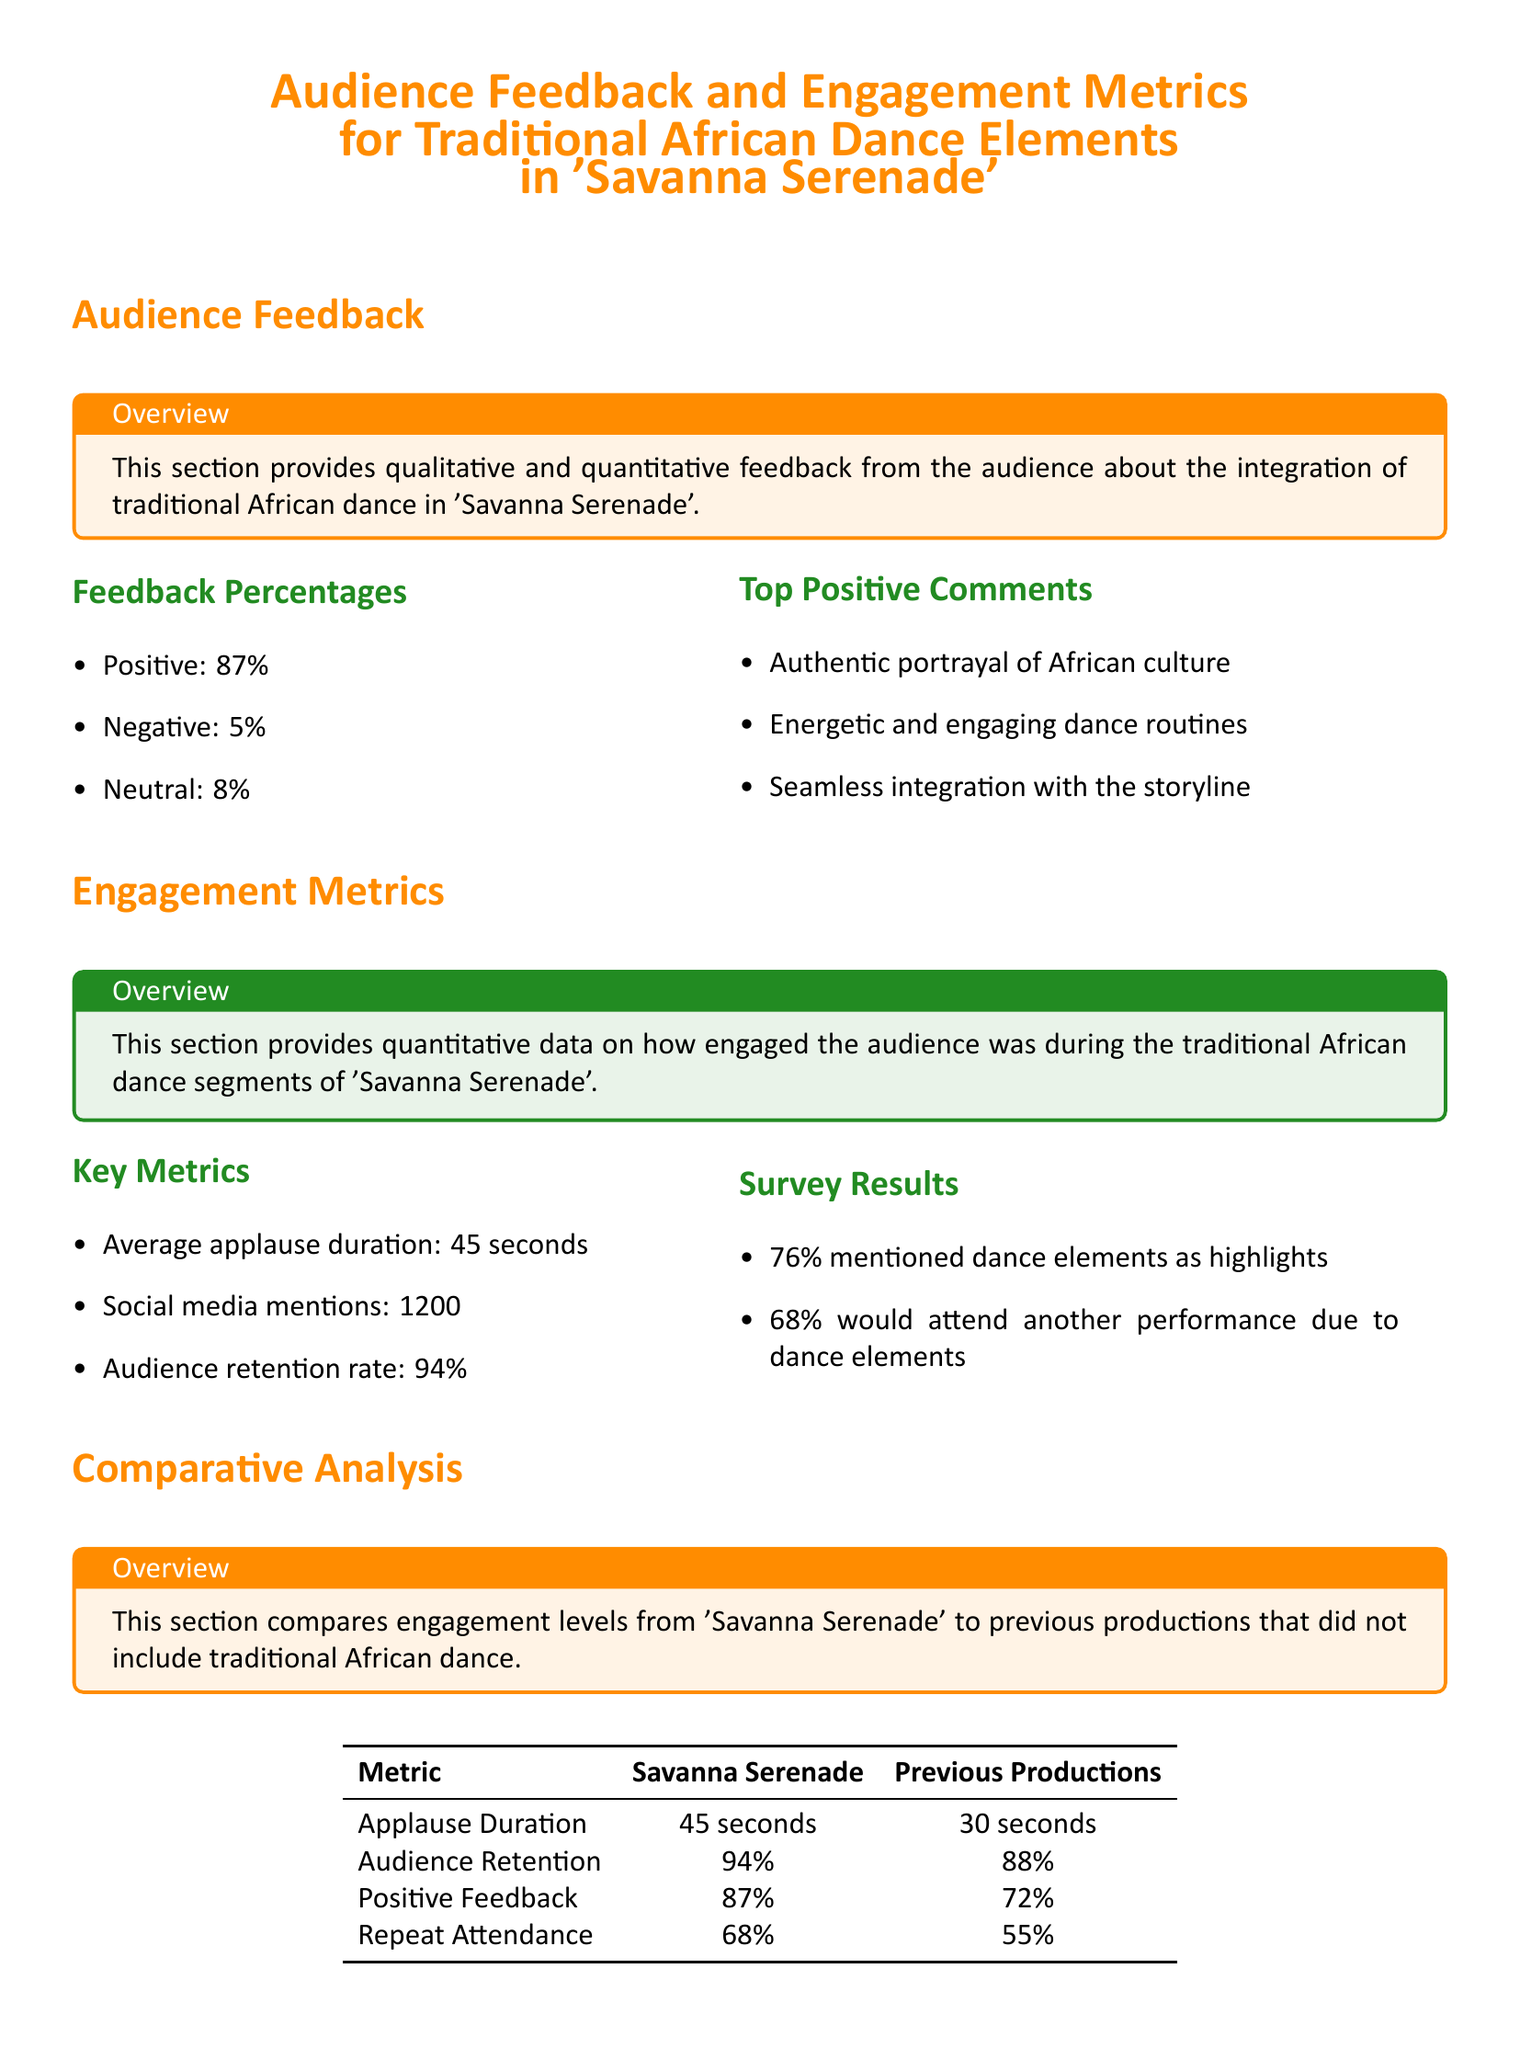What percentage of positive feedback was received? The percentage of positive feedback is presented in the document as one of the key metrics, specifically noting it as 87%.
Answer: 87% What is the average applause duration for the dance segments? The document provides the average applause duration as one of the key engagement metrics, specifically noted as 45 seconds.
Answer: 45 seconds What percent of the audience mentioned dance elements as highlights? The survey results section specifies that 76% of the audience mentioned dance elements as highlights in their feedback.
Answer: 76% What was the audience retention rate for 'Savanna Serenade'? The audience retention rate is listed in the engagement metrics, explicitly noted as 94%.
Answer: 94% What recommendation is suggested to increase audience understanding? The recommendations section notes the need to increase cultural context explanations to aid audience understanding.
Answer: Increase cultural context explanations How does the applause duration of 'Savanna Serenade' compare to previous productions? The document compares the applause duration of 'Savanna Serenade' to previous productions, stating that it was 45 seconds for 'Savanna Serenade' and 30 seconds for previous productions.
Answer: 45 seconds vs 30 seconds What was the social media mention count for 'Savanna Serenade'? The document mentions that there were 1200 social media mentions related to 'Savanna Serenade'.
Answer: 1200 What percentage of the audience would attend another performance due to dance elements? The survey results indicate that 68% of the audience expressed willingness to attend another performance because of the dance elements.
Answer: 68% What is the contrasting positive feedback percentage between 'Savanna Serenade' and previous productions? The document compares the positive feedback percentage: 87% for 'Savanna Serenade' and 72% for previous productions.
Answer: 87% vs 72% 